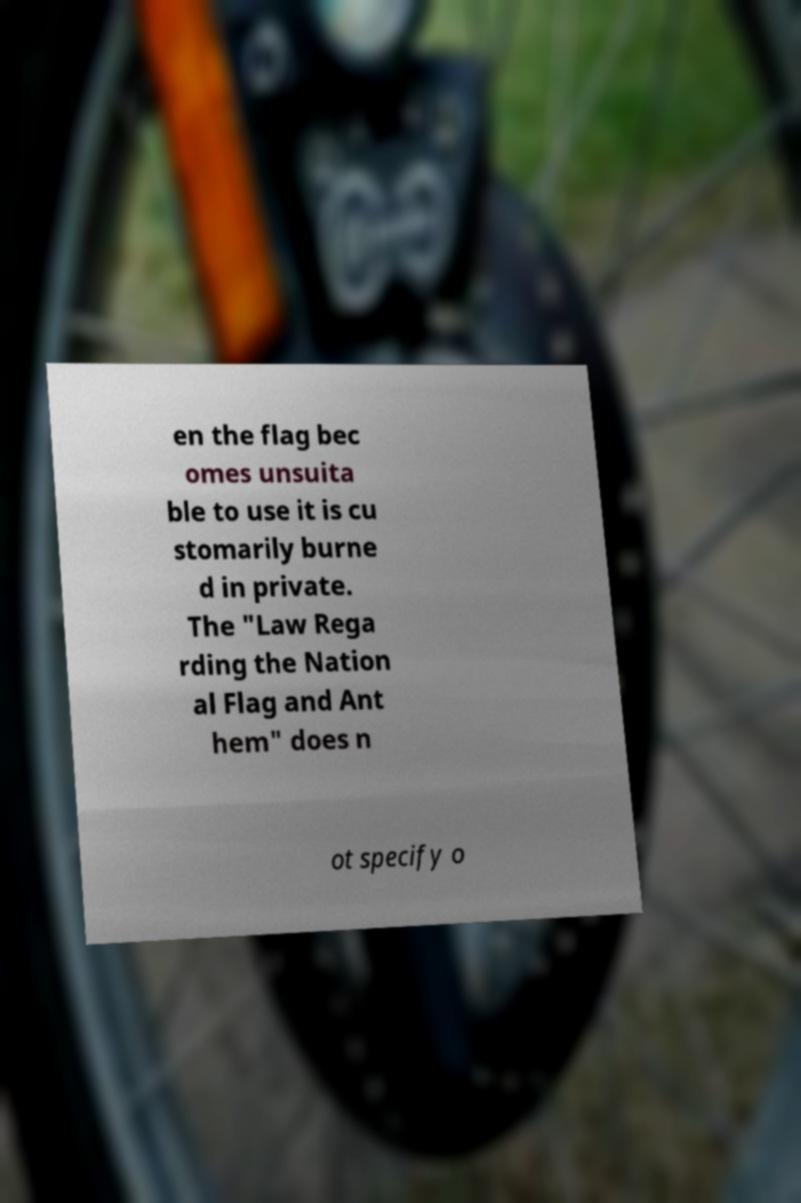Can you read and provide the text displayed in the image?This photo seems to have some interesting text. Can you extract and type it out for me? en the flag bec omes unsuita ble to use it is cu stomarily burne d in private. The "Law Rega rding the Nation al Flag and Ant hem" does n ot specify o 